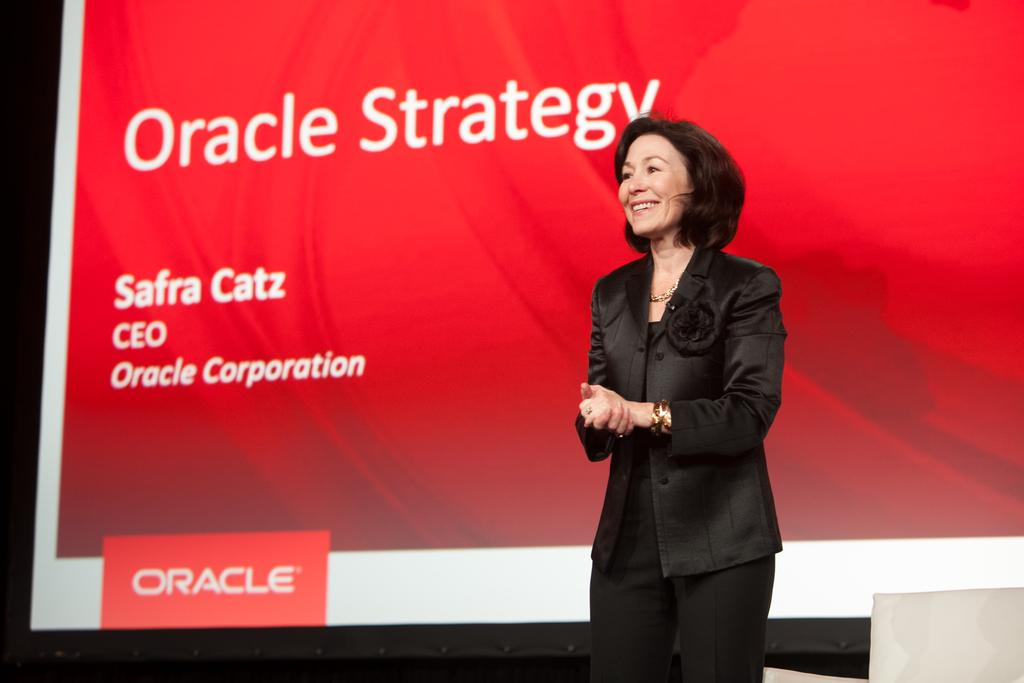Who is present in the image? There is a woman in the image. What is the woman doing in the image? The woman is standing in the image. What is the woman's facial expression in the image? The woman is smiling in the image. What can be seen in the background of the image? There is a poster with text in the background of the image. How many legs does the woman's son have in the image? There is no son present in the image, so it is not possible to determine the number of legs he might have. 